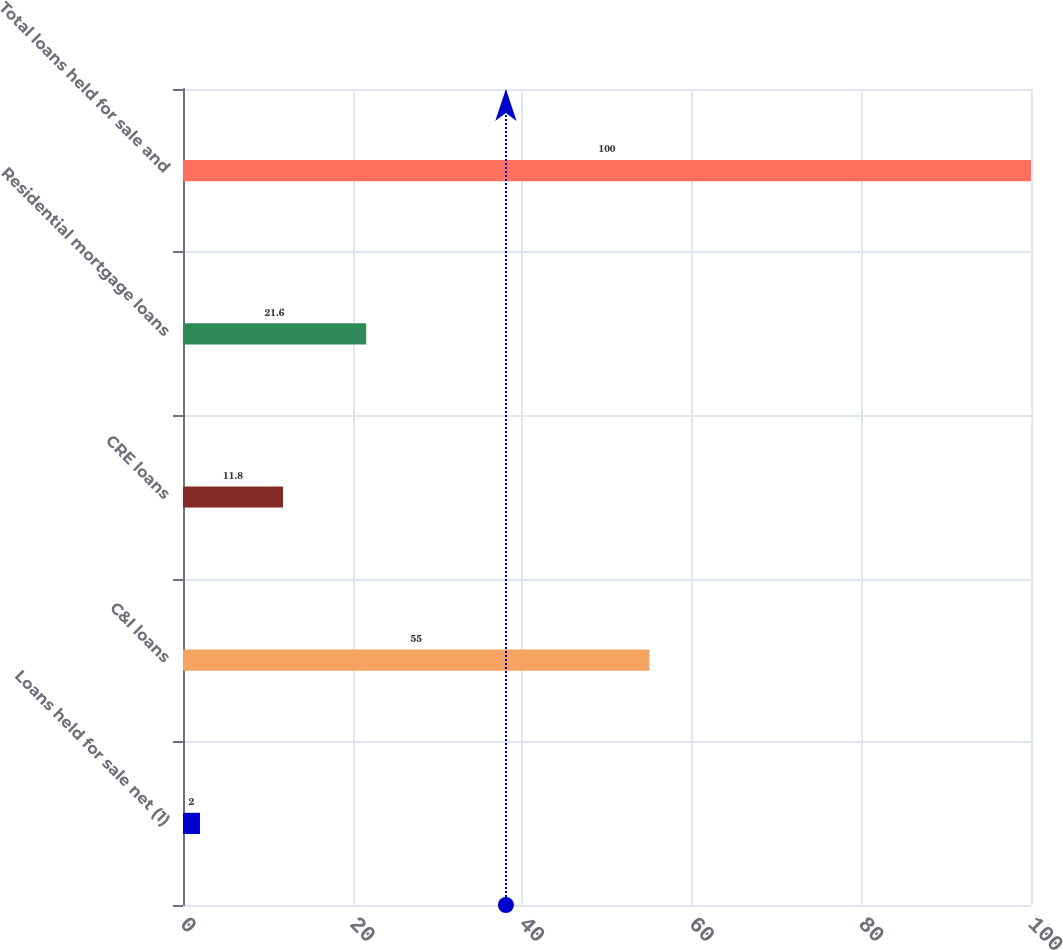Convert chart. <chart><loc_0><loc_0><loc_500><loc_500><bar_chart><fcel>Loans held for sale net (1)<fcel>C&I loans<fcel>CRE loans<fcel>Residential mortgage loans<fcel>Total loans held for sale and<nl><fcel>2<fcel>55<fcel>11.8<fcel>21.6<fcel>100<nl></chart> 